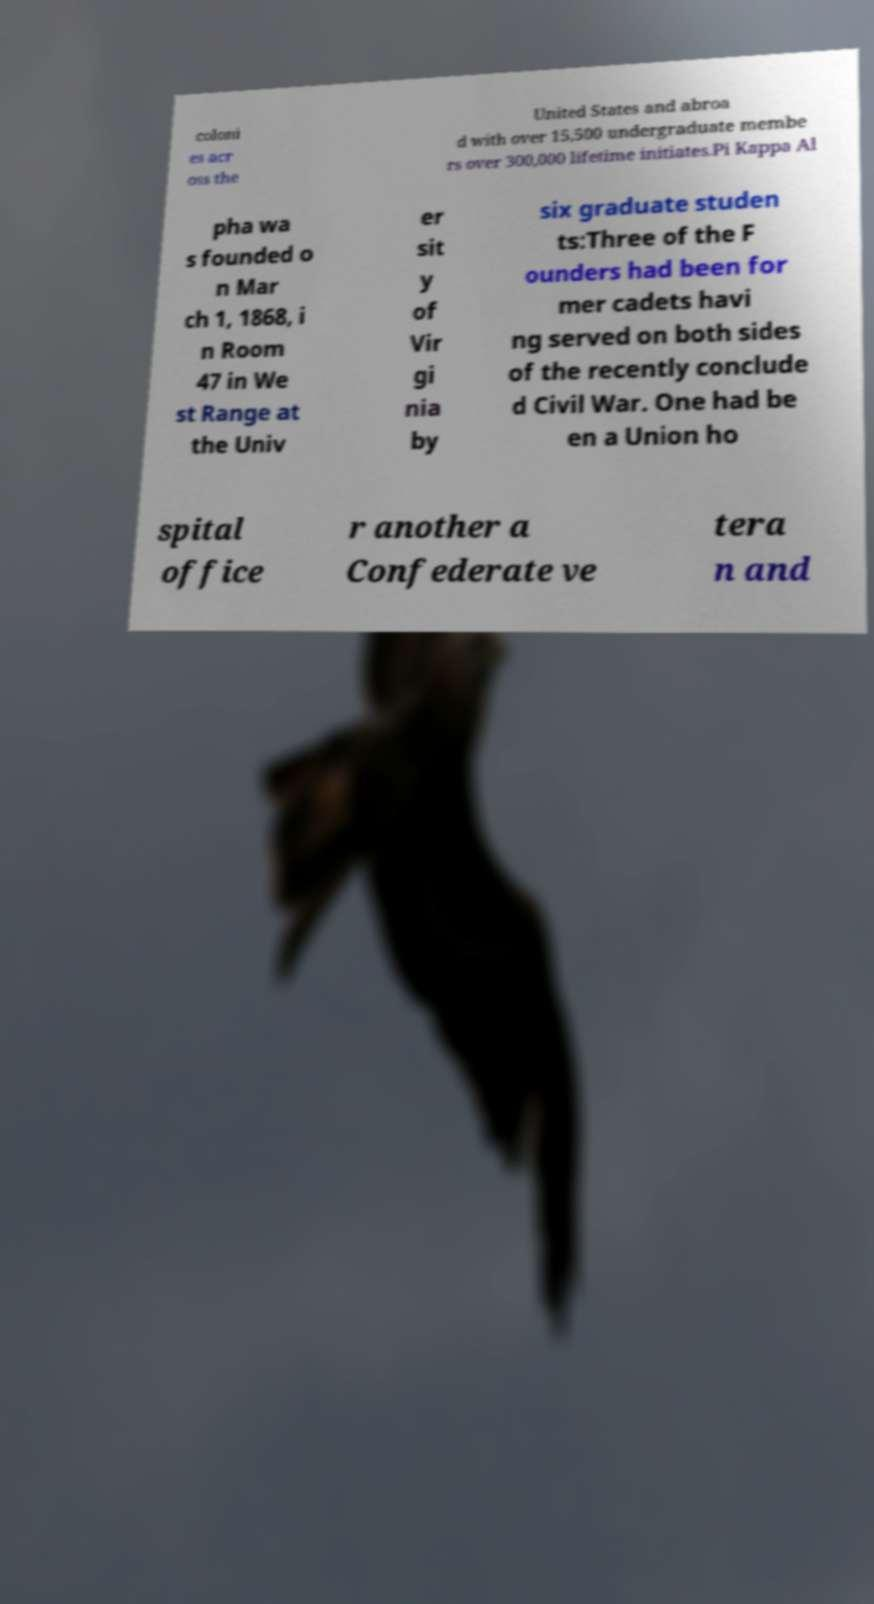Could you extract and type out the text from this image? coloni es acr oss the United States and abroa d with over 15,500 undergraduate membe rs over 300,000 lifetime initiates.Pi Kappa Al pha wa s founded o n Mar ch 1, 1868, i n Room 47 in We st Range at the Univ er sit y of Vir gi nia by six graduate studen ts:Three of the F ounders had been for mer cadets havi ng served on both sides of the recently conclude d Civil War. One had be en a Union ho spital office r another a Confederate ve tera n and 